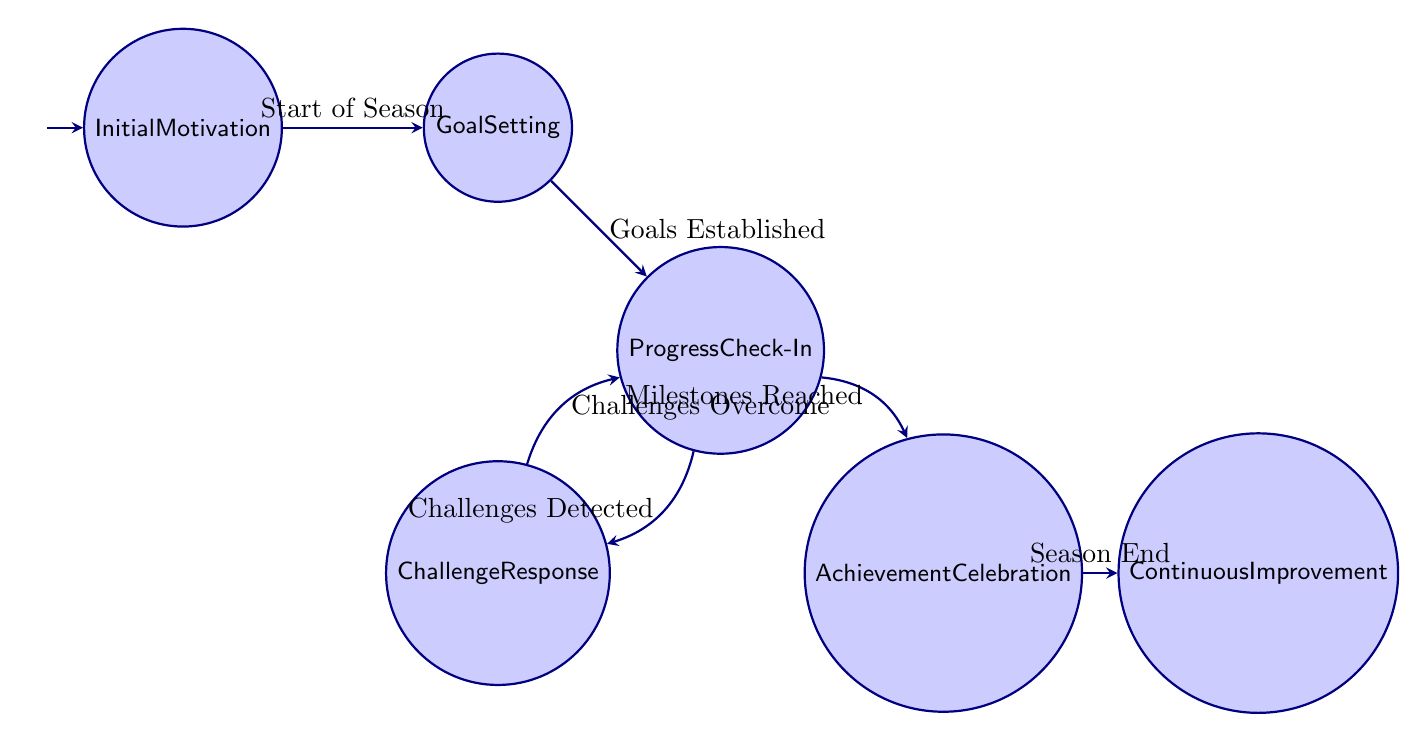What is the initial state of the workflow? The initial state is provided in the diagram and is labeled "Initial Motivation," indicating that this is the starting point of the flow.
Answer: Initial Motivation How many states are present in the diagram? By counting the different nodes depicted in the diagram, there are a total of six distinct states: Initial Motivation, Goal Setting, Progress Check-In, Challenge Response, Achievement Celebration, and Continuous Improvement.
Answer: 6 Which state follows "Goal Setting"? Based on the direction of the arrows drawn in the diagram, "Goal Setting" transitions directly to "Progress Check-In." This is the next state after establishing goals.
Answer: Progress Check-In What triggers the transition from "Progress Check-In" to "Achievement Celebration"? The transition is triggered by the event "Milestones Reached" as indicated on the arrow connecting these two states in the diagram.
Answer: Milestones Reached What happens after "Achievement Celebration"? After reaching this state, the workflow transitions to "Continuous Improvement," as indicated by the arrow leading out from Achievement Celebration.
Answer: Continuous Improvement If "Challenges Detected," which state does the workflow go to? The detection of challenges leads the workflow to transition to "Challenge Response," as specified by the directed arrow showing this transition.
Answer: Challenge Response What is the relationship between "Challenge Response" and "Progress Check-In"? The relationship is cyclical; after dealing with challenges, the workflow goes back to "Progress Check-In" when "Challenges Overcome" is achieved. This indicates a feedback loop designed for continuous assessment and improvement.
Answer: Cyclical relationship Which event indicates the start of the workflow? The workflow begins with the event labeled "Start of Season," which triggers the transition from the initial state to the next state in the flow.
Answer: Start of Season What is the final state in the motivational message workflow? The last state the workflow reaches after the "Achievement Celebration" is "Continuous Improvement," marking the end of the motivational journey for the team.
Answer: Continuous Improvement 